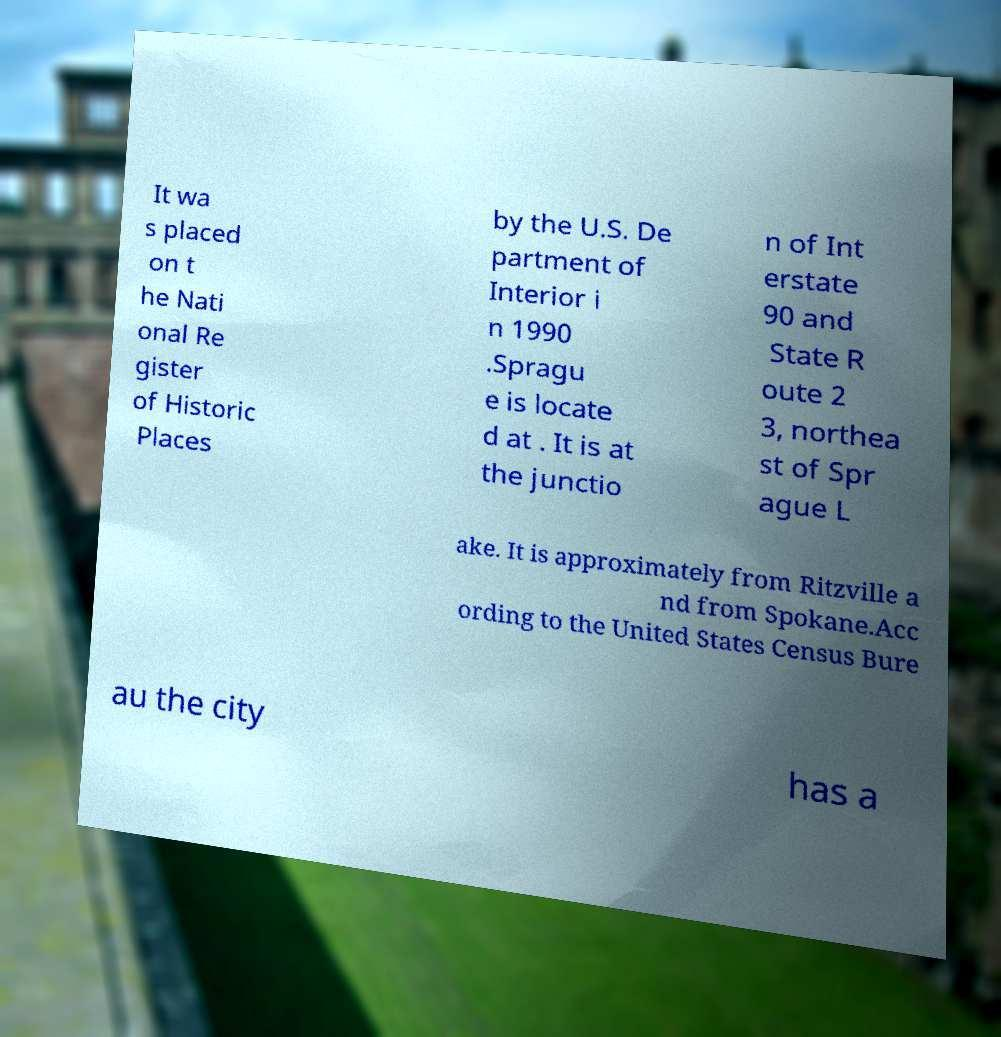Could you extract and type out the text from this image? It wa s placed on t he Nati onal Re gister of Historic Places by the U.S. De partment of Interior i n 1990 .Spragu e is locate d at . It is at the junctio n of Int erstate 90 and State R oute 2 3, northea st of Spr ague L ake. It is approximately from Ritzville a nd from Spokane.Acc ording to the United States Census Bure au the city has a 